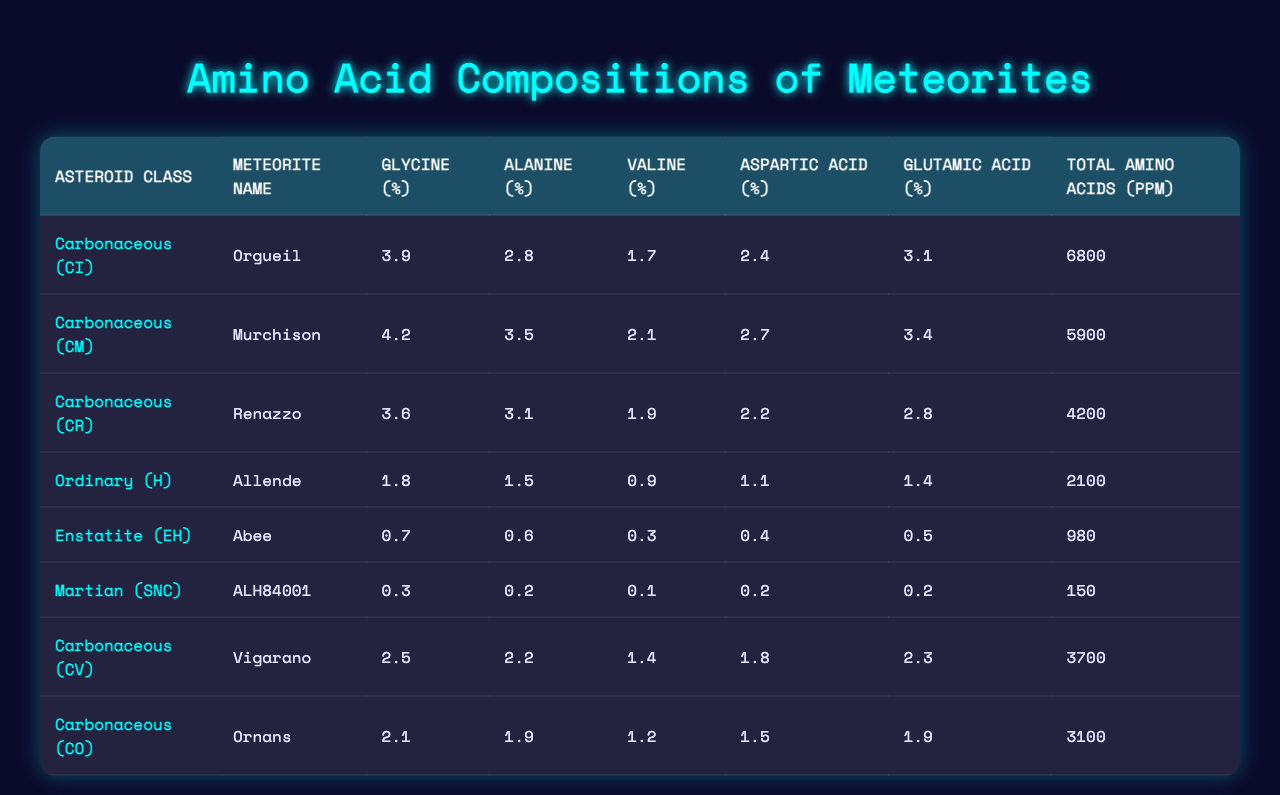What is the total amino acid content in the Murchison meteorite? The Murchison meteorite has a total amino acid content of 5900 ppm as listed in the table.
Answer: 5900 ppm Which asteroid class does the Renazzo meteorite belong to? The Renazzo meteorite is classified as Carbonaceous (CR) based on the first column of the table.
Answer: Carbonaceous (CR) What is the percentage of Glutamic Acid in the Allende meteorite? The Allende meteorite has a Glutamic Acid composition of 1.4% as shown in the table.
Answer: 1.4% Which meteorite has the highest Glycine percentage, and what is that percentage? The Murchison meteorite has the highest Glycine percentage at 4.2%, which can be found in the Glycine column of the table.
Answer: Murchison, 4.2% Is it true that the Abee meteorite contains more than 1% of Aspartic Acid? The Abee meteorite has Aspartic Acid at 0.4%, which is less than 1%, making the statement false.
Answer: False What is the average Valine percentage across the Carbonaceous asteroid classes? The Valine percentages for the Carbonaceous classes are: CI (1.7%), CM (2.1%), CR (1.9%), CV (1.4%), CO (1.2%). The average is (1.7 + 2.1 + 1.9 + 1.4 + 1.2)/5 = 1.66%.
Answer: 1.66% How much more Glycine does the Orgueil meteorite have compared to the Abee meteorite? The Glycine percentage in the Orgueil meteorite is 3.9% and in the Abee meteorite is 0.7%. The difference is 3.9% - 0.7% = 3.2%.
Answer: 3.2% Among the meteorites listed, which has the lowest total amino acid content, and what is that value? The Martian (SNC) meteorite ALH84001 has the lowest total amino acid content, which is 150 ppm, as indicated in the last column of the table.
Answer: ALH84001, 150 ppm What is the total percentage of Aspartic Acid and Glutamic Acid in the Vigarano meteorite? The Vigarano meteorite has Aspartic Acid at 1.8% and Glutamic Acid at 2.3%. The total is 1.8% + 2.3% = 4.1%.
Answer: 4.1% If the Alanine percentage is halved in the Renazzo meteorite, what would the new percentage be? The original Alanine percentage in the Renazzo meteorite is 3.1%. Halving it gives 3.1% / 2 = 1.55%.
Answer: 1.55% 